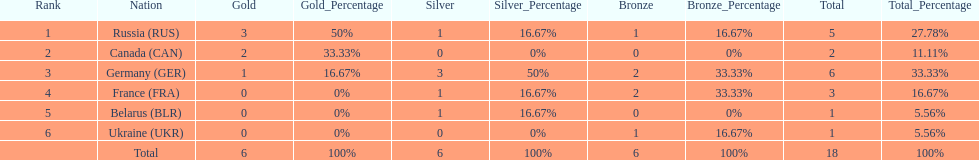What were the only 3 countries to win gold medals at the the 1994 winter olympics biathlon? Russia (RUS), Canada (CAN), Germany (GER). 